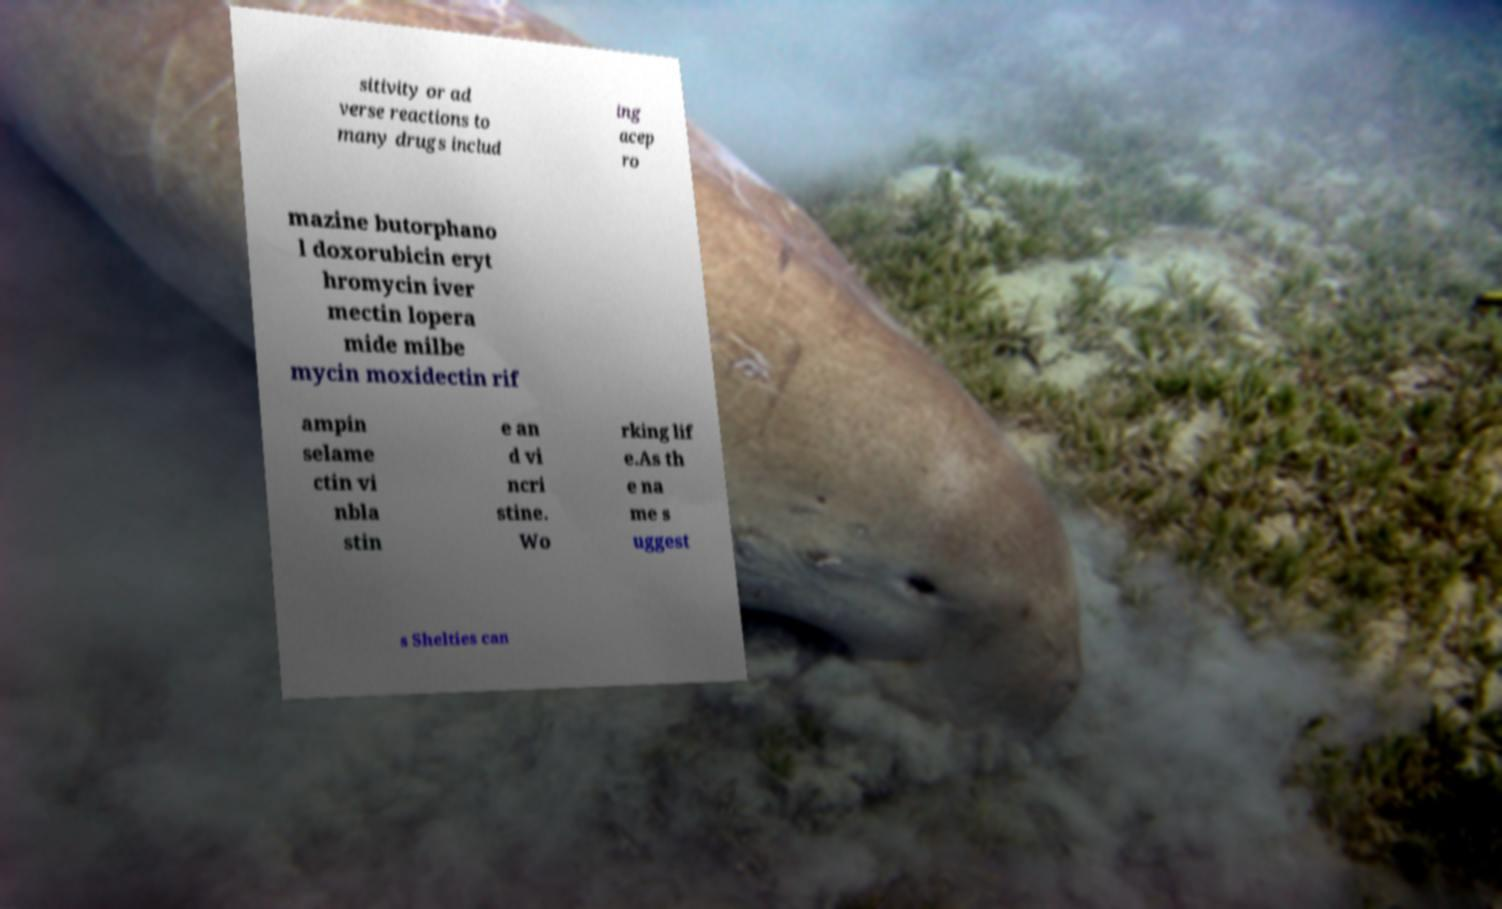I need the written content from this picture converted into text. Can you do that? sitivity or ad verse reactions to many drugs includ ing acep ro mazine butorphano l doxorubicin eryt hromycin iver mectin lopera mide milbe mycin moxidectin rif ampin selame ctin vi nbla stin e an d vi ncri stine. Wo rking lif e.As th e na me s uggest s Shelties can 